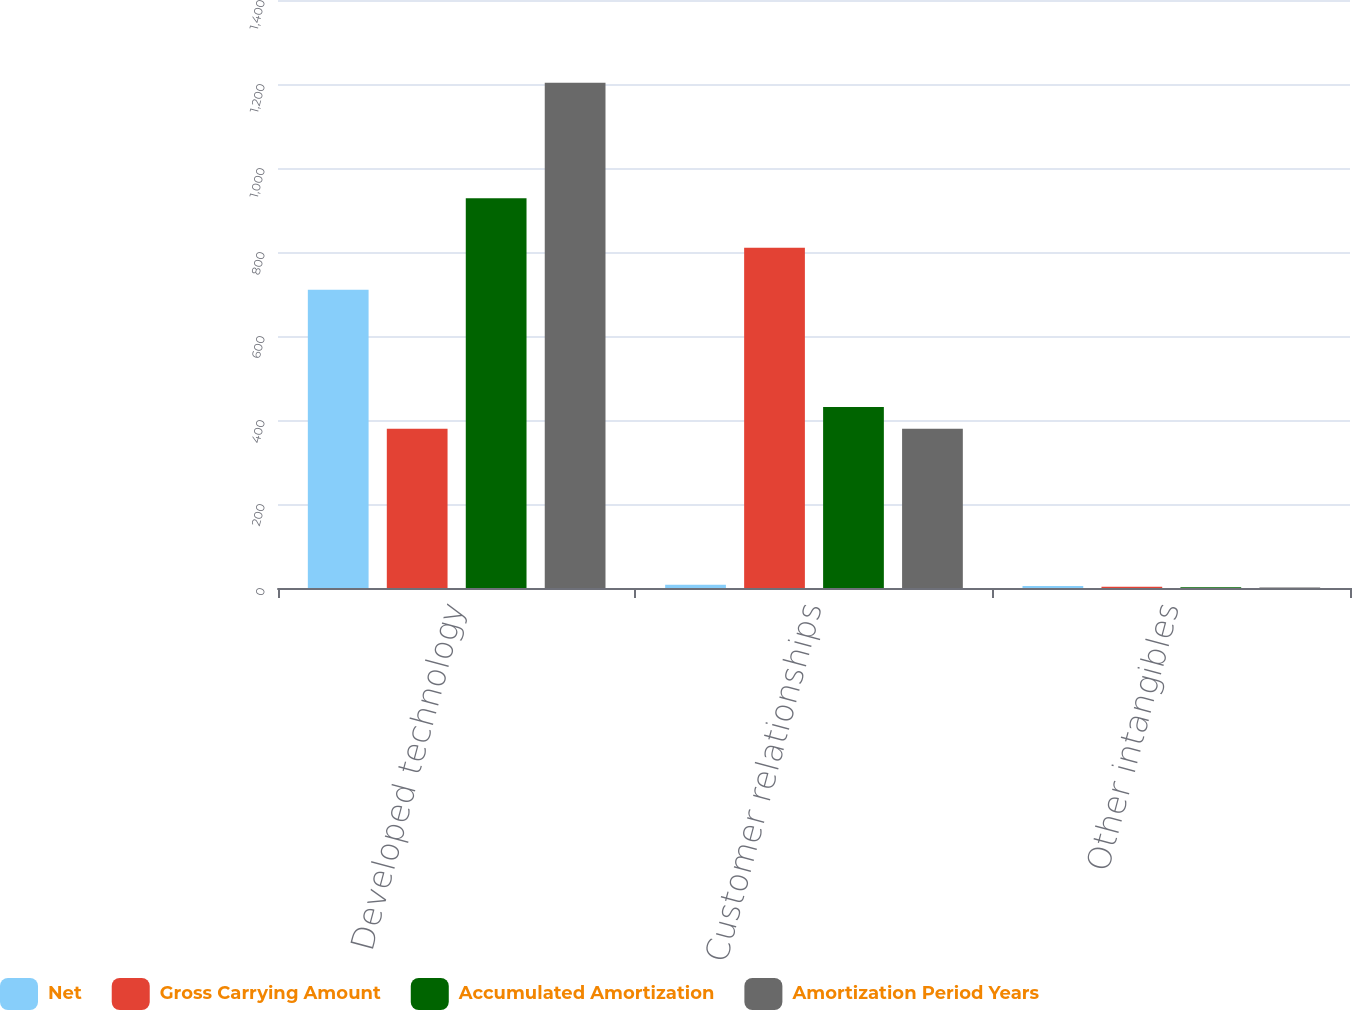<chart> <loc_0><loc_0><loc_500><loc_500><stacked_bar_chart><ecel><fcel>Developed technology<fcel>Customer relationships<fcel>Other intangibles<nl><fcel>Net<fcel>710<fcel>8<fcel>5<nl><fcel>Gross Carrying Amount<fcel>379<fcel>810<fcel>3<nl><fcel>Accumulated Amortization<fcel>928<fcel>431<fcel>2<nl><fcel>Amortization Period Years<fcel>1203<fcel>379<fcel>1<nl></chart> 